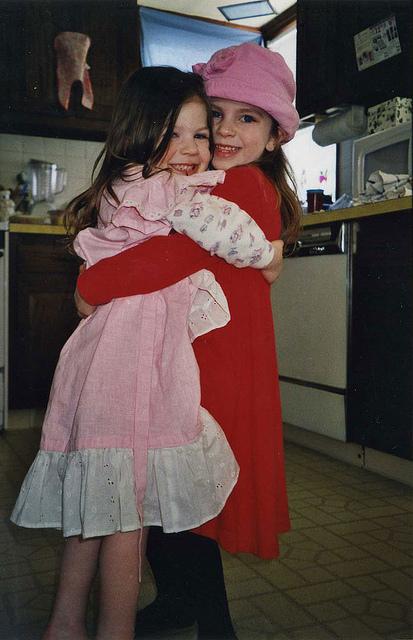What is the color of the woman's jacket?
Give a very brief answer. Red. Are these people looking at the camera?
Concise answer only. Yes. How many girls are wearing hats?
Be succinct. 1. Are the girls hugging?
Concise answer only. Yes. Is the woman in the hat carrying a purse?
Be succinct. No. What is this person holding?
Answer briefly. Child. Is the girl in pink wearing leggings?
Concise answer only. No. What are the people wearing on their backs?
Short answer required. Clothes. 